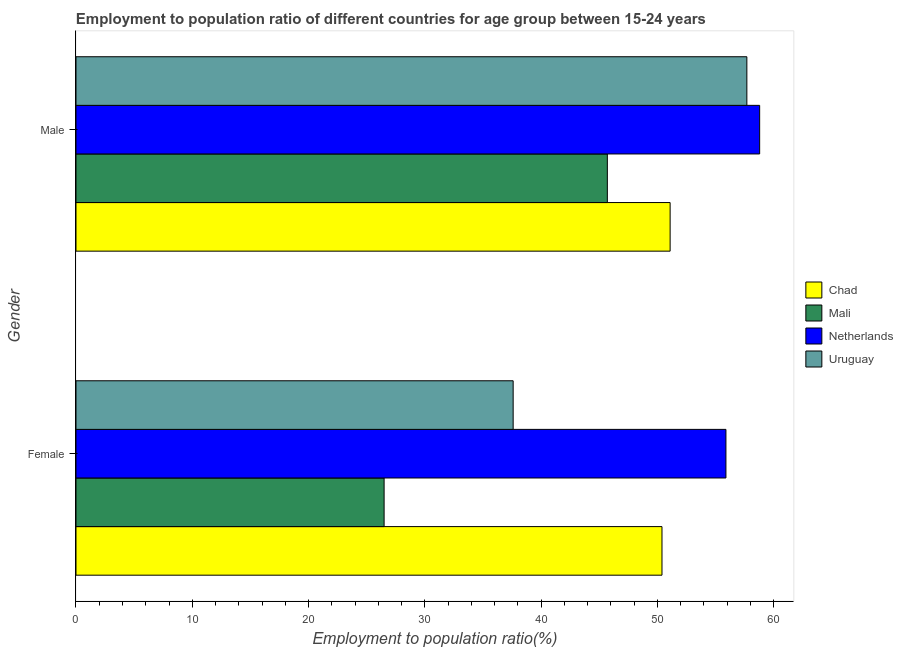How many groups of bars are there?
Give a very brief answer. 2. Are the number of bars per tick equal to the number of legend labels?
Make the answer very short. Yes. Are the number of bars on each tick of the Y-axis equal?
Your response must be concise. Yes. How many bars are there on the 1st tick from the top?
Keep it short and to the point. 4. How many bars are there on the 2nd tick from the bottom?
Give a very brief answer. 4. What is the employment to population ratio(female) in Netherlands?
Offer a terse response. 55.9. Across all countries, what is the maximum employment to population ratio(female)?
Your response must be concise. 55.9. Across all countries, what is the minimum employment to population ratio(female)?
Your answer should be very brief. 26.5. In which country was the employment to population ratio(male) minimum?
Offer a terse response. Mali. What is the total employment to population ratio(female) in the graph?
Ensure brevity in your answer.  170.4. What is the difference between the employment to population ratio(female) in Mali and that in Chad?
Your answer should be very brief. -23.9. What is the difference between the employment to population ratio(female) in Mali and the employment to population ratio(male) in Chad?
Your answer should be compact. -24.6. What is the average employment to population ratio(male) per country?
Ensure brevity in your answer.  53.32. What is the difference between the employment to population ratio(male) and employment to population ratio(female) in Uruguay?
Provide a succinct answer. 20.1. What is the ratio of the employment to population ratio(male) in Netherlands to that in Uruguay?
Your answer should be very brief. 1.02. Is the employment to population ratio(male) in Uruguay less than that in Mali?
Ensure brevity in your answer.  No. What does the 4th bar from the top in Female represents?
Make the answer very short. Chad. What does the 4th bar from the bottom in Male represents?
Give a very brief answer. Uruguay. How many bars are there?
Give a very brief answer. 8. Are all the bars in the graph horizontal?
Ensure brevity in your answer.  Yes. How many countries are there in the graph?
Your response must be concise. 4. Does the graph contain any zero values?
Make the answer very short. No. Where does the legend appear in the graph?
Keep it short and to the point. Center right. How are the legend labels stacked?
Your response must be concise. Vertical. What is the title of the graph?
Your answer should be compact. Employment to population ratio of different countries for age group between 15-24 years. What is the label or title of the Y-axis?
Provide a succinct answer. Gender. What is the Employment to population ratio(%) of Chad in Female?
Your response must be concise. 50.4. What is the Employment to population ratio(%) in Mali in Female?
Your response must be concise. 26.5. What is the Employment to population ratio(%) in Netherlands in Female?
Provide a short and direct response. 55.9. What is the Employment to population ratio(%) of Uruguay in Female?
Ensure brevity in your answer.  37.6. What is the Employment to population ratio(%) of Chad in Male?
Provide a short and direct response. 51.1. What is the Employment to population ratio(%) in Mali in Male?
Offer a terse response. 45.7. What is the Employment to population ratio(%) of Netherlands in Male?
Provide a short and direct response. 58.8. What is the Employment to population ratio(%) in Uruguay in Male?
Offer a very short reply. 57.7. Across all Gender, what is the maximum Employment to population ratio(%) in Chad?
Provide a succinct answer. 51.1. Across all Gender, what is the maximum Employment to population ratio(%) of Mali?
Offer a very short reply. 45.7. Across all Gender, what is the maximum Employment to population ratio(%) in Netherlands?
Ensure brevity in your answer.  58.8. Across all Gender, what is the maximum Employment to population ratio(%) in Uruguay?
Your answer should be compact. 57.7. Across all Gender, what is the minimum Employment to population ratio(%) of Chad?
Your answer should be compact. 50.4. Across all Gender, what is the minimum Employment to population ratio(%) in Netherlands?
Offer a terse response. 55.9. Across all Gender, what is the minimum Employment to population ratio(%) of Uruguay?
Give a very brief answer. 37.6. What is the total Employment to population ratio(%) in Chad in the graph?
Keep it short and to the point. 101.5. What is the total Employment to population ratio(%) of Mali in the graph?
Keep it short and to the point. 72.2. What is the total Employment to population ratio(%) in Netherlands in the graph?
Ensure brevity in your answer.  114.7. What is the total Employment to population ratio(%) in Uruguay in the graph?
Your answer should be compact. 95.3. What is the difference between the Employment to population ratio(%) in Mali in Female and that in Male?
Provide a short and direct response. -19.2. What is the difference between the Employment to population ratio(%) of Uruguay in Female and that in Male?
Keep it short and to the point. -20.1. What is the difference between the Employment to population ratio(%) in Chad in Female and the Employment to population ratio(%) in Uruguay in Male?
Provide a succinct answer. -7.3. What is the difference between the Employment to population ratio(%) of Mali in Female and the Employment to population ratio(%) of Netherlands in Male?
Offer a very short reply. -32.3. What is the difference between the Employment to population ratio(%) in Mali in Female and the Employment to population ratio(%) in Uruguay in Male?
Give a very brief answer. -31.2. What is the difference between the Employment to population ratio(%) in Netherlands in Female and the Employment to population ratio(%) in Uruguay in Male?
Provide a succinct answer. -1.8. What is the average Employment to population ratio(%) of Chad per Gender?
Your answer should be very brief. 50.75. What is the average Employment to population ratio(%) of Mali per Gender?
Your answer should be compact. 36.1. What is the average Employment to population ratio(%) of Netherlands per Gender?
Provide a short and direct response. 57.35. What is the average Employment to population ratio(%) in Uruguay per Gender?
Ensure brevity in your answer.  47.65. What is the difference between the Employment to population ratio(%) of Chad and Employment to population ratio(%) of Mali in Female?
Give a very brief answer. 23.9. What is the difference between the Employment to population ratio(%) of Chad and Employment to population ratio(%) of Uruguay in Female?
Your answer should be compact. 12.8. What is the difference between the Employment to population ratio(%) in Mali and Employment to population ratio(%) in Netherlands in Female?
Offer a very short reply. -29.4. What is the difference between the Employment to population ratio(%) in Mali and Employment to population ratio(%) in Uruguay in Female?
Your answer should be compact. -11.1. What is the difference between the Employment to population ratio(%) of Chad and Employment to population ratio(%) of Mali in Male?
Provide a succinct answer. 5.4. What is the difference between the Employment to population ratio(%) of Chad and Employment to population ratio(%) of Netherlands in Male?
Your answer should be compact. -7.7. What is the difference between the Employment to population ratio(%) of Chad and Employment to population ratio(%) of Uruguay in Male?
Provide a short and direct response. -6.6. What is the difference between the Employment to population ratio(%) of Mali and Employment to population ratio(%) of Netherlands in Male?
Provide a short and direct response. -13.1. What is the difference between the Employment to population ratio(%) of Mali and Employment to population ratio(%) of Uruguay in Male?
Offer a terse response. -12. What is the difference between the Employment to population ratio(%) in Netherlands and Employment to population ratio(%) in Uruguay in Male?
Your answer should be very brief. 1.1. What is the ratio of the Employment to population ratio(%) in Chad in Female to that in Male?
Keep it short and to the point. 0.99. What is the ratio of the Employment to population ratio(%) of Mali in Female to that in Male?
Offer a terse response. 0.58. What is the ratio of the Employment to population ratio(%) in Netherlands in Female to that in Male?
Offer a terse response. 0.95. What is the ratio of the Employment to population ratio(%) in Uruguay in Female to that in Male?
Your response must be concise. 0.65. What is the difference between the highest and the second highest Employment to population ratio(%) of Chad?
Your response must be concise. 0.7. What is the difference between the highest and the second highest Employment to population ratio(%) of Mali?
Offer a terse response. 19.2. What is the difference between the highest and the second highest Employment to population ratio(%) in Netherlands?
Your answer should be compact. 2.9. What is the difference between the highest and the second highest Employment to population ratio(%) of Uruguay?
Make the answer very short. 20.1. What is the difference between the highest and the lowest Employment to population ratio(%) of Mali?
Offer a terse response. 19.2. What is the difference between the highest and the lowest Employment to population ratio(%) in Netherlands?
Your response must be concise. 2.9. What is the difference between the highest and the lowest Employment to population ratio(%) in Uruguay?
Your answer should be very brief. 20.1. 